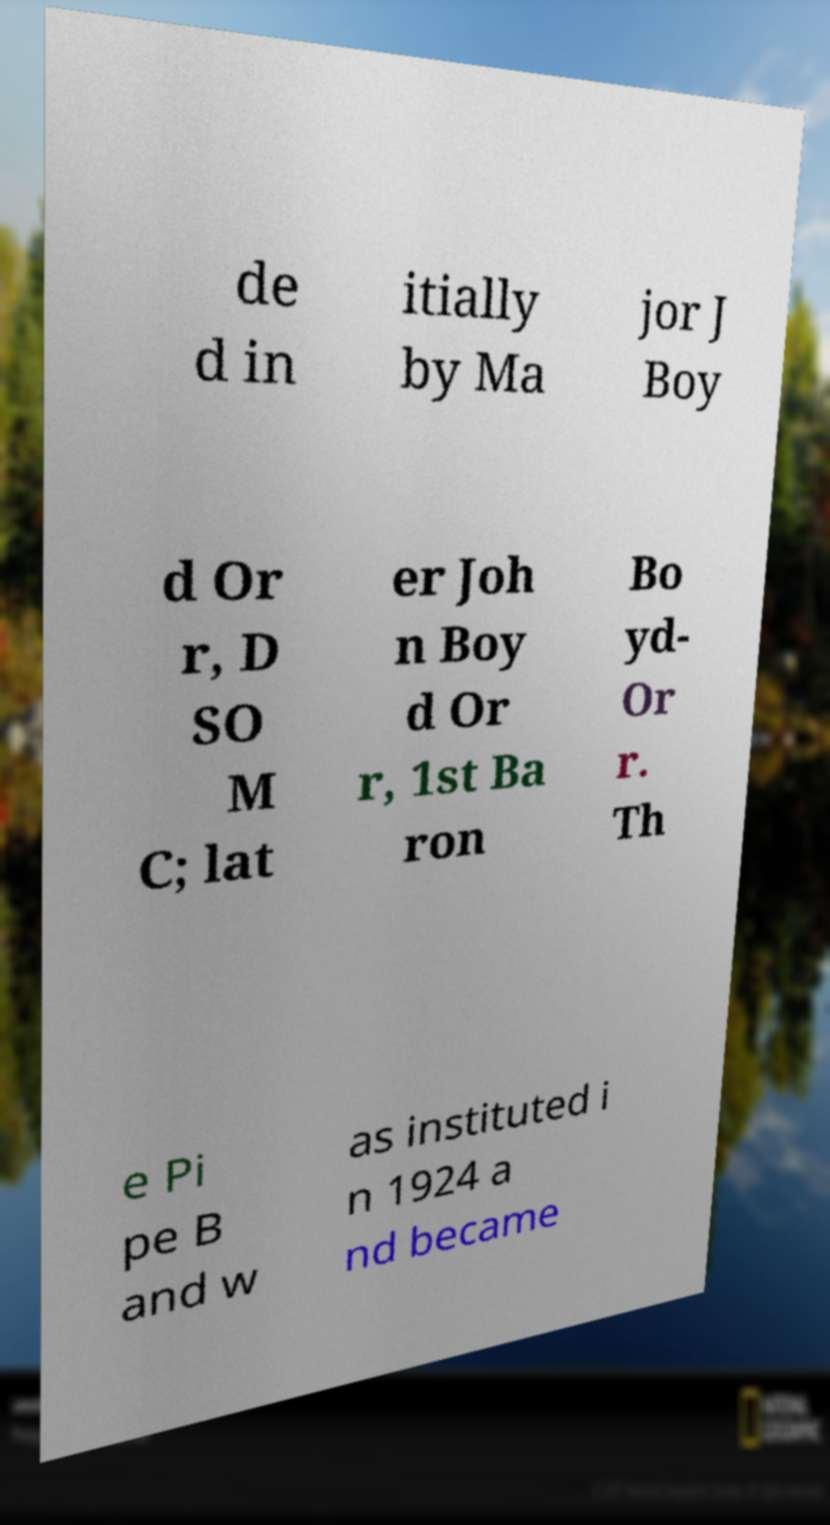Can you read and provide the text displayed in the image?This photo seems to have some interesting text. Can you extract and type it out for me? de d in itially by Ma jor J Boy d Or r, D SO M C; lat er Joh n Boy d Or r, 1st Ba ron Bo yd- Or r. Th e Pi pe B and w as instituted i n 1924 a nd became 